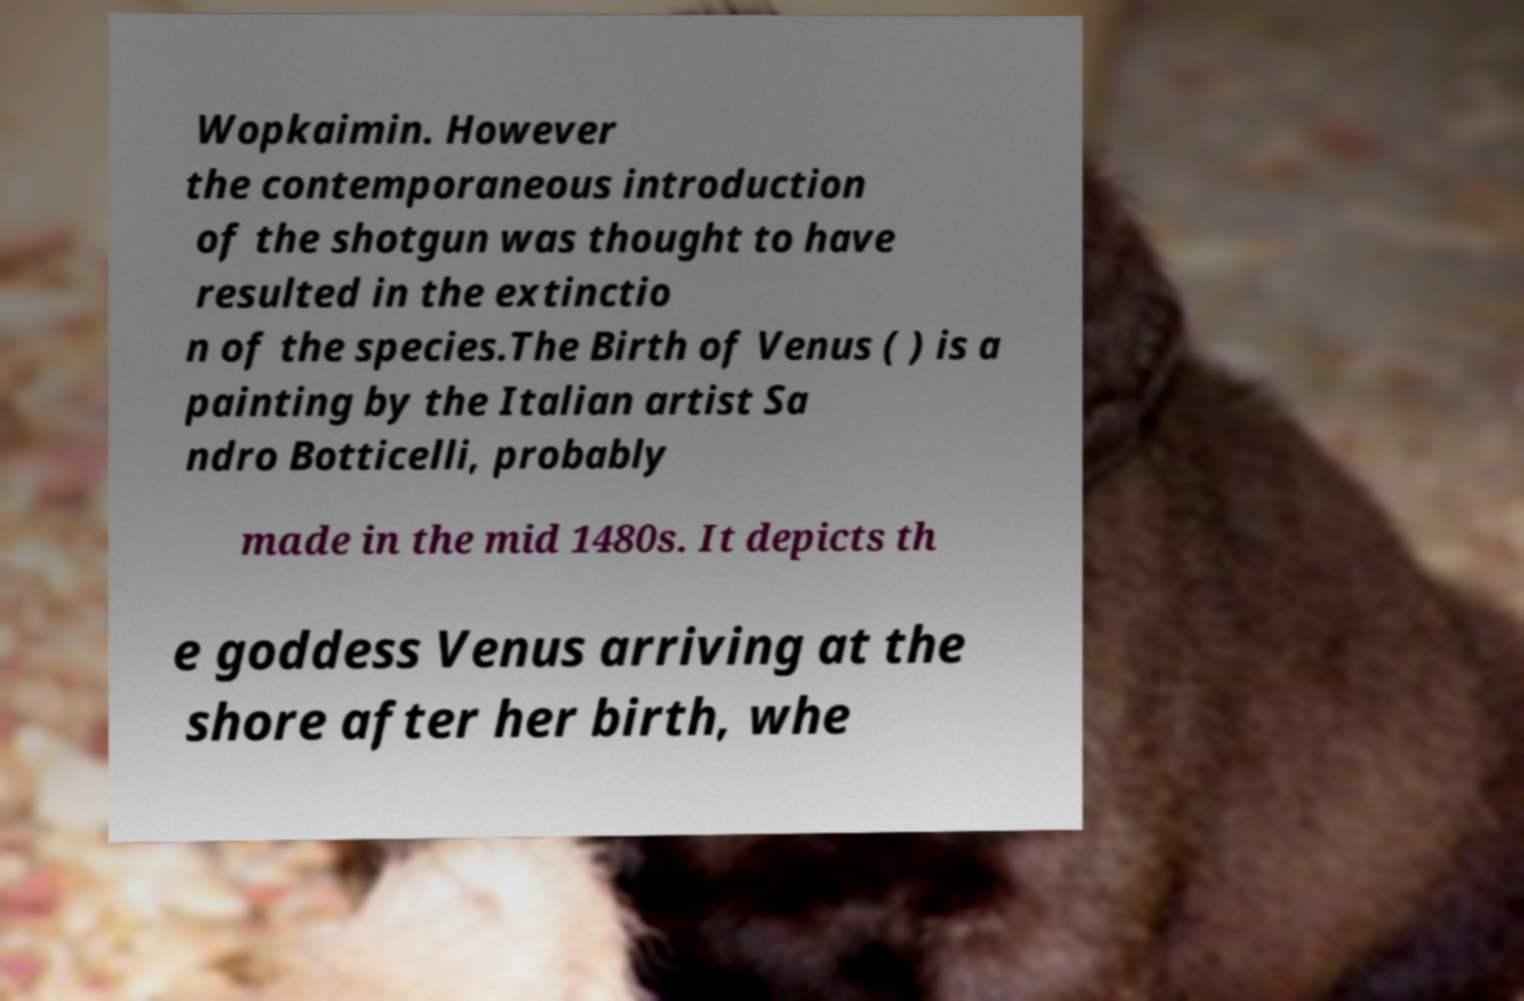Please read and relay the text visible in this image. What does it say? Wopkaimin. However the contemporaneous introduction of the shotgun was thought to have resulted in the extinctio n of the species.The Birth of Venus ( ) is a painting by the Italian artist Sa ndro Botticelli, probably made in the mid 1480s. It depicts th e goddess Venus arriving at the shore after her birth, whe 